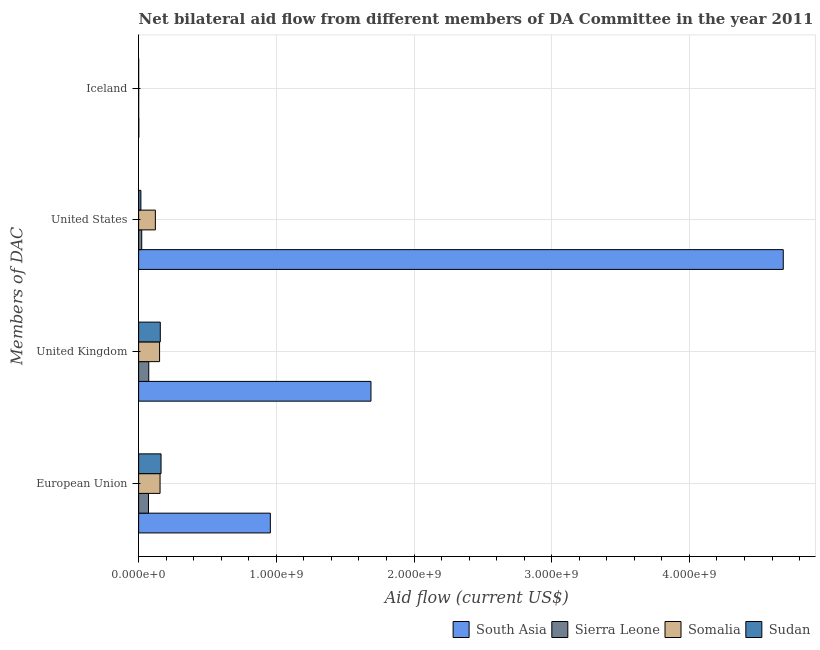How many different coloured bars are there?
Offer a terse response. 4. Are the number of bars per tick equal to the number of legend labels?
Keep it short and to the point. Yes. How many bars are there on the 1st tick from the bottom?
Provide a short and direct response. 4. What is the amount of aid given by us in Sudan?
Keep it short and to the point. 1.64e+07. Across all countries, what is the maximum amount of aid given by iceland?
Your response must be concise. 1.37e+06. Across all countries, what is the minimum amount of aid given by us?
Your answer should be compact. 1.64e+07. In which country was the amount of aid given by iceland maximum?
Give a very brief answer. South Asia. In which country was the amount of aid given by us minimum?
Your response must be concise. Sudan. What is the total amount of aid given by uk in the graph?
Make the answer very short. 2.07e+09. What is the difference between the amount of aid given by uk in South Asia and that in Sudan?
Your answer should be compact. 1.53e+09. What is the difference between the amount of aid given by eu in South Asia and the amount of aid given by uk in Sudan?
Your response must be concise. 7.99e+08. What is the average amount of aid given by eu per country?
Your answer should be compact. 3.37e+08. What is the difference between the amount of aid given by us and amount of aid given by iceland in South Asia?
Make the answer very short. 4.68e+09. In how many countries, is the amount of aid given by eu greater than 4600000000 US$?
Give a very brief answer. 0. What is the ratio of the amount of aid given by us in Sierra Leone to that in Somalia?
Ensure brevity in your answer.  0.19. Is the amount of aid given by eu in Sudan less than that in South Asia?
Offer a very short reply. Yes. What is the difference between the highest and the second highest amount of aid given by eu?
Make the answer very short. 7.94e+08. What is the difference between the highest and the lowest amount of aid given by eu?
Keep it short and to the point. 8.85e+08. In how many countries, is the amount of aid given by uk greater than the average amount of aid given by uk taken over all countries?
Ensure brevity in your answer.  1. What does the 2nd bar from the bottom in Iceland represents?
Give a very brief answer. Sierra Leone. Is it the case that in every country, the sum of the amount of aid given by eu and amount of aid given by uk is greater than the amount of aid given by us?
Your answer should be compact. No. How many bars are there?
Ensure brevity in your answer.  16. Are all the bars in the graph horizontal?
Make the answer very short. Yes. Does the graph contain any zero values?
Give a very brief answer. No. Does the graph contain grids?
Your answer should be compact. Yes. Where does the legend appear in the graph?
Your answer should be very brief. Bottom right. What is the title of the graph?
Provide a short and direct response. Net bilateral aid flow from different members of DA Committee in the year 2011. Does "Peru" appear as one of the legend labels in the graph?
Offer a very short reply. No. What is the label or title of the X-axis?
Make the answer very short. Aid flow (current US$). What is the label or title of the Y-axis?
Provide a succinct answer. Members of DAC. What is the Aid flow (current US$) of South Asia in European Union?
Your answer should be compact. 9.57e+08. What is the Aid flow (current US$) in Sierra Leone in European Union?
Make the answer very short. 7.16e+07. What is the Aid flow (current US$) of Somalia in European Union?
Provide a short and direct response. 1.56e+08. What is the Aid flow (current US$) in Sudan in European Union?
Your response must be concise. 1.63e+08. What is the Aid flow (current US$) of South Asia in United Kingdom?
Make the answer very short. 1.69e+09. What is the Aid flow (current US$) of Sierra Leone in United Kingdom?
Your answer should be compact. 7.36e+07. What is the Aid flow (current US$) in Somalia in United Kingdom?
Ensure brevity in your answer.  1.52e+08. What is the Aid flow (current US$) of Sudan in United Kingdom?
Your answer should be compact. 1.57e+08. What is the Aid flow (current US$) in South Asia in United States?
Provide a short and direct response. 4.68e+09. What is the Aid flow (current US$) in Sierra Leone in United States?
Your answer should be very brief. 2.26e+07. What is the Aid flow (current US$) in Somalia in United States?
Your answer should be very brief. 1.21e+08. What is the Aid flow (current US$) in Sudan in United States?
Give a very brief answer. 1.64e+07. What is the Aid flow (current US$) of South Asia in Iceland?
Provide a succinct answer. 1.37e+06. What is the Aid flow (current US$) in Sierra Leone in Iceland?
Your answer should be very brief. 9.00e+04. What is the Aid flow (current US$) in Somalia in Iceland?
Your response must be concise. 2.60e+05. Across all Members of DAC, what is the maximum Aid flow (current US$) of South Asia?
Offer a very short reply. 4.68e+09. Across all Members of DAC, what is the maximum Aid flow (current US$) in Sierra Leone?
Ensure brevity in your answer.  7.36e+07. Across all Members of DAC, what is the maximum Aid flow (current US$) of Somalia?
Make the answer very short. 1.56e+08. Across all Members of DAC, what is the maximum Aid flow (current US$) in Sudan?
Give a very brief answer. 1.63e+08. Across all Members of DAC, what is the minimum Aid flow (current US$) in South Asia?
Your answer should be very brief. 1.37e+06. Across all Members of DAC, what is the minimum Aid flow (current US$) in Sierra Leone?
Ensure brevity in your answer.  9.00e+04. Across all Members of DAC, what is the minimum Aid flow (current US$) of Somalia?
Provide a short and direct response. 2.60e+05. Across all Members of DAC, what is the minimum Aid flow (current US$) of Sudan?
Offer a terse response. 6.00e+04. What is the total Aid flow (current US$) of South Asia in the graph?
Provide a short and direct response. 7.33e+09. What is the total Aid flow (current US$) of Sierra Leone in the graph?
Offer a terse response. 1.68e+08. What is the total Aid flow (current US$) in Somalia in the graph?
Ensure brevity in your answer.  4.30e+08. What is the total Aid flow (current US$) in Sudan in the graph?
Make the answer very short. 3.37e+08. What is the difference between the Aid flow (current US$) in South Asia in European Union and that in United Kingdom?
Make the answer very short. -7.31e+08. What is the difference between the Aid flow (current US$) in Sierra Leone in European Union and that in United Kingdom?
Keep it short and to the point. -2.01e+06. What is the difference between the Aid flow (current US$) of Somalia in European Union and that in United Kingdom?
Provide a short and direct response. 3.54e+06. What is the difference between the Aid flow (current US$) of Sudan in European Union and that in United Kingdom?
Offer a very short reply. 5.52e+06. What is the difference between the Aid flow (current US$) of South Asia in European Union and that in United States?
Your answer should be compact. -3.73e+09. What is the difference between the Aid flow (current US$) in Sierra Leone in European Union and that in United States?
Give a very brief answer. 4.90e+07. What is the difference between the Aid flow (current US$) of Somalia in European Union and that in United States?
Keep it short and to the point. 3.42e+07. What is the difference between the Aid flow (current US$) of Sudan in European Union and that in United States?
Your answer should be compact. 1.46e+08. What is the difference between the Aid flow (current US$) in South Asia in European Union and that in Iceland?
Give a very brief answer. 9.55e+08. What is the difference between the Aid flow (current US$) in Sierra Leone in European Union and that in Iceland?
Provide a succinct answer. 7.15e+07. What is the difference between the Aid flow (current US$) in Somalia in European Union and that in Iceland?
Offer a terse response. 1.55e+08. What is the difference between the Aid flow (current US$) in Sudan in European Union and that in Iceland?
Ensure brevity in your answer.  1.63e+08. What is the difference between the Aid flow (current US$) in South Asia in United Kingdom and that in United States?
Ensure brevity in your answer.  -2.99e+09. What is the difference between the Aid flow (current US$) in Sierra Leone in United Kingdom and that in United States?
Offer a terse response. 5.10e+07. What is the difference between the Aid flow (current US$) of Somalia in United Kingdom and that in United States?
Your answer should be very brief. 3.07e+07. What is the difference between the Aid flow (current US$) in Sudan in United Kingdom and that in United States?
Ensure brevity in your answer.  1.41e+08. What is the difference between the Aid flow (current US$) of South Asia in United Kingdom and that in Iceland?
Your answer should be compact. 1.69e+09. What is the difference between the Aid flow (current US$) of Sierra Leone in United Kingdom and that in Iceland?
Your answer should be compact. 7.35e+07. What is the difference between the Aid flow (current US$) of Somalia in United Kingdom and that in Iceland?
Ensure brevity in your answer.  1.52e+08. What is the difference between the Aid flow (current US$) of Sudan in United Kingdom and that in Iceland?
Provide a short and direct response. 1.57e+08. What is the difference between the Aid flow (current US$) of South Asia in United States and that in Iceland?
Give a very brief answer. 4.68e+09. What is the difference between the Aid flow (current US$) of Sierra Leone in United States and that in Iceland?
Give a very brief answer. 2.25e+07. What is the difference between the Aid flow (current US$) in Somalia in United States and that in Iceland?
Give a very brief answer. 1.21e+08. What is the difference between the Aid flow (current US$) in Sudan in United States and that in Iceland?
Your answer should be very brief. 1.64e+07. What is the difference between the Aid flow (current US$) of South Asia in European Union and the Aid flow (current US$) of Sierra Leone in United Kingdom?
Provide a succinct answer. 8.83e+08. What is the difference between the Aid flow (current US$) in South Asia in European Union and the Aid flow (current US$) in Somalia in United Kingdom?
Ensure brevity in your answer.  8.04e+08. What is the difference between the Aid flow (current US$) of South Asia in European Union and the Aid flow (current US$) of Sudan in United Kingdom?
Your response must be concise. 7.99e+08. What is the difference between the Aid flow (current US$) of Sierra Leone in European Union and the Aid flow (current US$) of Somalia in United Kingdom?
Your response must be concise. -8.06e+07. What is the difference between the Aid flow (current US$) of Sierra Leone in European Union and the Aid flow (current US$) of Sudan in United Kingdom?
Offer a very short reply. -8.58e+07. What is the difference between the Aid flow (current US$) of Somalia in European Union and the Aid flow (current US$) of Sudan in United Kingdom?
Give a very brief answer. -1.66e+06. What is the difference between the Aid flow (current US$) in South Asia in European Union and the Aid flow (current US$) in Sierra Leone in United States?
Ensure brevity in your answer.  9.34e+08. What is the difference between the Aid flow (current US$) of South Asia in European Union and the Aid flow (current US$) of Somalia in United States?
Provide a short and direct response. 8.35e+08. What is the difference between the Aid flow (current US$) of South Asia in European Union and the Aid flow (current US$) of Sudan in United States?
Give a very brief answer. 9.40e+08. What is the difference between the Aid flow (current US$) in Sierra Leone in European Union and the Aid flow (current US$) in Somalia in United States?
Provide a succinct answer. -4.99e+07. What is the difference between the Aid flow (current US$) in Sierra Leone in European Union and the Aid flow (current US$) in Sudan in United States?
Your response must be concise. 5.51e+07. What is the difference between the Aid flow (current US$) in Somalia in European Union and the Aid flow (current US$) in Sudan in United States?
Keep it short and to the point. 1.39e+08. What is the difference between the Aid flow (current US$) in South Asia in European Union and the Aid flow (current US$) in Sierra Leone in Iceland?
Your answer should be very brief. 9.56e+08. What is the difference between the Aid flow (current US$) of South Asia in European Union and the Aid flow (current US$) of Somalia in Iceland?
Provide a short and direct response. 9.56e+08. What is the difference between the Aid flow (current US$) of South Asia in European Union and the Aid flow (current US$) of Sudan in Iceland?
Provide a short and direct response. 9.57e+08. What is the difference between the Aid flow (current US$) of Sierra Leone in European Union and the Aid flow (current US$) of Somalia in Iceland?
Provide a succinct answer. 7.13e+07. What is the difference between the Aid flow (current US$) of Sierra Leone in European Union and the Aid flow (current US$) of Sudan in Iceland?
Provide a short and direct response. 7.15e+07. What is the difference between the Aid flow (current US$) in Somalia in European Union and the Aid flow (current US$) in Sudan in Iceland?
Offer a terse response. 1.56e+08. What is the difference between the Aid flow (current US$) of South Asia in United Kingdom and the Aid flow (current US$) of Sierra Leone in United States?
Give a very brief answer. 1.66e+09. What is the difference between the Aid flow (current US$) in South Asia in United Kingdom and the Aid flow (current US$) in Somalia in United States?
Offer a very short reply. 1.57e+09. What is the difference between the Aid flow (current US$) in South Asia in United Kingdom and the Aid flow (current US$) in Sudan in United States?
Provide a short and direct response. 1.67e+09. What is the difference between the Aid flow (current US$) of Sierra Leone in United Kingdom and the Aid flow (current US$) of Somalia in United States?
Provide a short and direct response. -4.79e+07. What is the difference between the Aid flow (current US$) in Sierra Leone in United Kingdom and the Aid flow (current US$) in Sudan in United States?
Keep it short and to the point. 5.71e+07. What is the difference between the Aid flow (current US$) in Somalia in United Kingdom and the Aid flow (current US$) in Sudan in United States?
Your response must be concise. 1.36e+08. What is the difference between the Aid flow (current US$) of South Asia in United Kingdom and the Aid flow (current US$) of Sierra Leone in Iceland?
Ensure brevity in your answer.  1.69e+09. What is the difference between the Aid flow (current US$) in South Asia in United Kingdom and the Aid flow (current US$) in Somalia in Iceland?
Your answer should be compact. 1.69e+09. What is the difference between the Aid flow (current US$) of South Asia in United Kingdom and the Aid flow (current US$) of Sudan in Iceland?
Make the answer very short. 1.69e+09. What is the difference between the Aid flow (current US$) in Sierra Leone in United Kingdom and the Aid flow (current US$) in Somalia in Iceland?
Keep it short and to the point. 7.33e+07. What is the difference between the Aid flow (current US$) of Sierra Leone in United Kingdom and the Aid flow (current US$) of Sudan in Iceland?
Offer a very short reply. 7.35e+07. What is the difference between the Aid flow (current US$) in Somalia in United Kingdom and the Aid flow (current US$) in Sudan in Iceland?
Keep it short and to the point. 1.52e+08. What is the difference between the Aid flow (current US$) of South Asia in United States and the Aid flow (current US$) of Sierra Leone in Iceland?
Make the answer very short. 4.68e+09. What is the difference between the Aid flow (current US$) in South Asia in United States and the Aid flow (current US$) in Somalia in Iceland?
Provide a succinct answer. 4.68e+09. What is the difference between the Aid flow (current US$) of South Asia in United States and the Aid flow (current US$) of Sudan in Iceland?
Your response must be concise. 4.68e+09. What is the difference between the Aid flow (current US$) of Sierra Leone in United States and the Aid flow (current US$) of Somalia in Iceland?
Provide a short and direct response. 2.23e+07. What is the difference between the Aid flow (current US$) of Sierra Leone in United States and the Aid flow (current US$) of Sudan in Iceland?
Give a very brief answer. 2.25e+07. What is the difference between the Aid flow (current US$) in Somalia in United States and the Aid flow (current US$) in Sudan in Iceland?
Your answer should be very brief. 1.21e+08. What is the average Aid flow (current US$) of South Asia per Members of DAC?
Offer a terse response. 1.83e+09. What is the average Aid flow (current US$) of Sierra Leone per Members of DAC?
Make the answer very short. 4.19e+07. What is the average Aid flow (current US$) of Somalia per Members of DAC?
Your response must be concise. 1.07e+08. What is the average Aid flow (current US$) of Sudan per Members of DAC?
Provide a succinct answer. 8.42e+07. What is the difference between the Aid flow (current US$) in South Asia and Aid flow (current US$) in Sierra Leone in European Union?
Your answer should be compact. 8.85e+08. What is the difference between the Aid flow (current US$) in South Asia and Aid flow (current US$) in Somalia in European Union?
Give a very brief answer. 8.01e+08. What is the difference between the Aid flow (current US$) in South Asia and Aid flow (current US$) in Sudan in European Union?
Offer a very short reply. 7.94e+08. What is the difference between the Aid flow (current US$) in Sierra Leone and Aid flow (current US$) in Somalia in European Union?
Offer a very short reply. -8.41e+07. What is the difference between the Aid flow (current US$) of Sierra Leone and Aid flow (current US$) of Sudan in European Union?
Ensure brevity in your answer.  -9.13e+07. What is the difference between the Aid flow (current US$) of Somalia and Aid flow (current US$) of Sudan in European Union?
Ensure brevity in your answer.  -7.18e+06. What is the difference between the Aid flow (current US$) in South Asia and Aid flow (current US$) in Sierra Leone in United Kingdom?
Offer a very short reply. 1.61e+09. What is the difference between the Aid flow (current US$) of South Asia and Aid flow (current US$) of Somalia in United Kingdom?
Provide a succinct answer. 1.54e+09. What is the difference between the Aid flow (current US$) of South Asia and Aid flow (current US$) of Sudan in United Kingdom?
Keep it short and to the point. 1.53e+09. What is the difference between the Aid flow (current US$) of Sierra Leone and Aid flow (current US$) of Somalia in United Kingdom?
Provide a short and direct response. -7.86e+07. What is the difference between the Aid flow (current US$) of Sierra Leone and Aid flow (current US$) of Sudan in United Kingdom?
Keep it short and to the point. -8.38e+07. What is the difference between the Aid flow (current US$) in Somalia and Aid flow (current US$) in Sudan in United Kingdom?
Offer a terse response. -5.20e+06. What is the difference between the Aid flow (current US$) of South Asia and Aid flow (current US$) of Sierra Leone in United States?
Give a very brief answer. 4.66e+09. What is the difference between the Aid flow (current US$) in South Asia and Aid flow (current US$) in Somalia in United States?
Offer a terse response. 4.56e+09. What is the difference between the Aid flow (current US$) in South Asia and Aid flow (current US$) in Sudan in United States?
Keep it short and to the point. 4.67e+09. What is the difference between the Aid flow (current US$) in Sierra Leone and Aid flow (current US$) in Somalia in United States?
Provide a succinct answer. -9.89e+07. What is the difference between the Aid flow (current US$) of Sierra Leone and Aid flow (current US$) of Sudan in United States?
Your response must be concise. 6.11e+06. What is the difference between the Aid flow (current US$) of Somalia and Aid flow (current US$) of Sudan in United States?
Give a very brief answer. 1.05e+08. What is the difference between the Aid flow (current US$) of South Asia and Aid flow (current US$) of Sierra Leone in Iceland?
Your answer should be very brief. 1.28e+06. What is the difference between the Aid flow (current US$) of South Asia and Aid flow (current US$) of Somalia in Iceland?
Offer a very short reply. 1.11e+06. What is the difference between the Aid flow (current US$) of South Asia and Aid flow (current US$) of Sudan in Iceland?
Provide a short and direct response. 1.31e+06. What is the difference between the Aid flow (current US$) of Sierra Leone and Aid flow (current US$) of Sudan in Iceland?
Your answer should be very brief. 3.00e+04. What is the difference between the Aid flow (current US$) in Somalia and Aid flow (current US$) in Sudan in Iceland?
Offer a very short reply. 2.00e+05. What is the ratio of the Aid flow (current US$) in South Asia in European Union to that in United Kingdom?
Your answer should be very brief. 0.57. What is the ratio of the Aid flow (current US$) of Sierra Leone in European Union to that in United Kingdom?
Your answer should be compact. 0.97. What is the ratio of the Aid flow (current US$) in Somalia in European Union to that in United Kingdom?
Your answer should be very brief. 1.02. What is the ratio of the Aid flow (current US$) of Sudan in European Union to that in United Kingdom?
Keep it short and to the point. 1.04. What is the ratio of the Aid flow (current US$) of South Asia in European Union to that in United States?
Give a very brief answer. 0.2. What is the ratio of the Aid flow (current US$) of Sierra Leone in European Union to that in United States?
Your answer should be very brief. 3.17. What is the ratio of the Aid flow (current US$) of Somalia in European Union to that in United States?
Ensure brevity in your answer.  1.28. What is the ratio of the Aid flow (current US$) in Sudan in European Union to that in United States?
Ensure brevity in your answer.  9.9. What is the ratio of the Aid flow (current US$) of South Asia in European Union to that in Iceland?
Provide a succinct answer. 698.23. What is the ratio of the Aid flow (current US$) in Sierra Leone in European Union to that in Iceland?
Ensure brevity in your answer.  795. What is the ratio of the Aid flow (current US$) in Somalia in European Union to that in Iceland?
Provide a short and direct response. 598.77. What is the ratio of the Aid flow (current US$) in Sudan in European Union to that in Iceland?
Your answer should be very brief. 2714.33. What is the ratio of the Aid flow (current US$) in South Asia in United Kingdom to that in United States?
Provide a short and direct response. 0.36. What is the ratio of the Aid flow (current US$) in Sierra Leone in United Kingdom to that in United States?
Your answer should be compact. 3.26. What is the ratio of the Aid flow (current US$) of Somalia in United Kingdom to that in United States?
Your response must be concise. 1.25. What is the ratio of the Aid flow (current US$) in Sudan in United Kingdom to that in United States?
Ensure brevity in your answer.  9.56. What is the ratio of the Aid flow (current US$) in South Asia in United Kingdom to that in Iceland?
Your answer should be compact. 1231.69. What is the ratio of the Aid flow (current US$) in Sierra Leone in United Kingdom to that in Iceland?
Your answer should be compact. 817.33. What is the ratio of the Aid flow (current US$) in Somalia in United Kingdom to that in Iceland?
Your answer should be very brief. 585.15. What is the ratio of the Aid flow (current US$) of Sudan in United Kingdom to that in Iceland?
Offer a terse response. 2622.33. What is the ratio of the Aid flow (current US$) in South Asia in United States to that in Iceland?
Offer a very short reply. 3417.38. What is the ratio of the Aid flow (current US$) in Sierra Leone in United States to that in Iceland?
Make the answer very short. 250.67. What is the ratio of the Aid flow (current US$) of Somalia in United States to that in Iceland?
Make the answer very short. 467.15. What is the ratio of the Aid flow (current US$) of Sudan in United States to that in Iceland?
Provide a succinct answer. 274.17. What is the difference between the highest and the second highest Aid flow (current US$) in South Asia?
Make the answer very short. 2.99e+09. What is the difference between the highest and the second highest Aid flow (current US$) in Sierra Leone?
Ensure brevity in your answer.  2.01e+06. What is the difference between the highest and the second highest Aid flow (current US$) of Somalia?
Offer a terse response. 3.54e+06. What is the difference between the highest and the second highest Aid flow (current US$) of Sudan?
Offer a very short reply. 5.52e+06. What is the difference between the highest and the lowest Aid flow (current US$) in South Asia?
Make the answer very short. 4.68e+09. What is the difference between the highest and the lowest Aid flow (current US$) of Sierra Leone?
Your response must be concise. 7.35e+07. What is the difference between the highest and the lowest Aid flow (current US$) in Somalia?
Your answer should be compact. 1.55e+08. What is the difference between the highest and the lowest Aid flow (current US$) of Sudan?
Offer a terse response. 1.63e+08. 